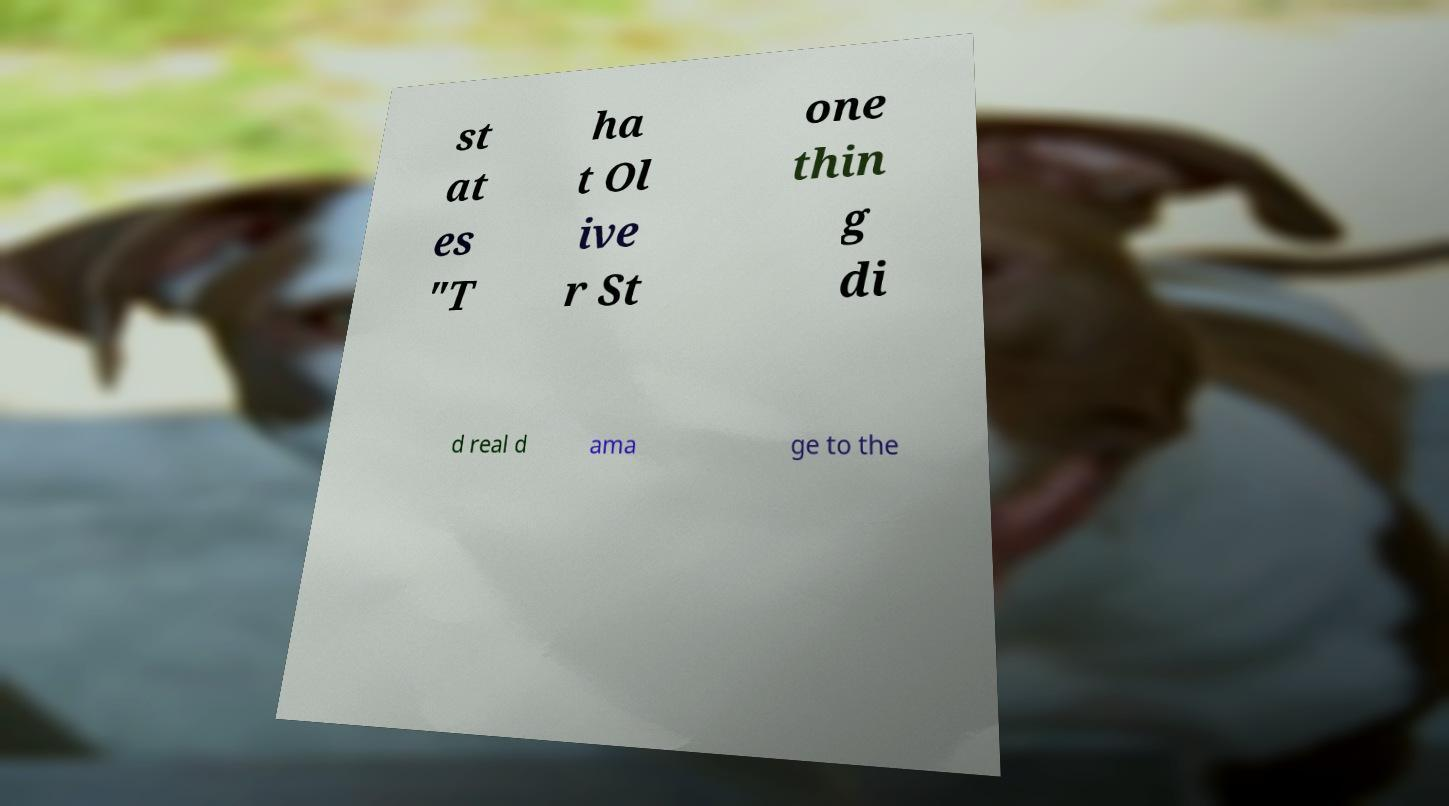Could you assist in decoding the text presented in this image and type it out clearly? st at es "T ha t Ol ive r St one thin g di d real d ama ge to the 